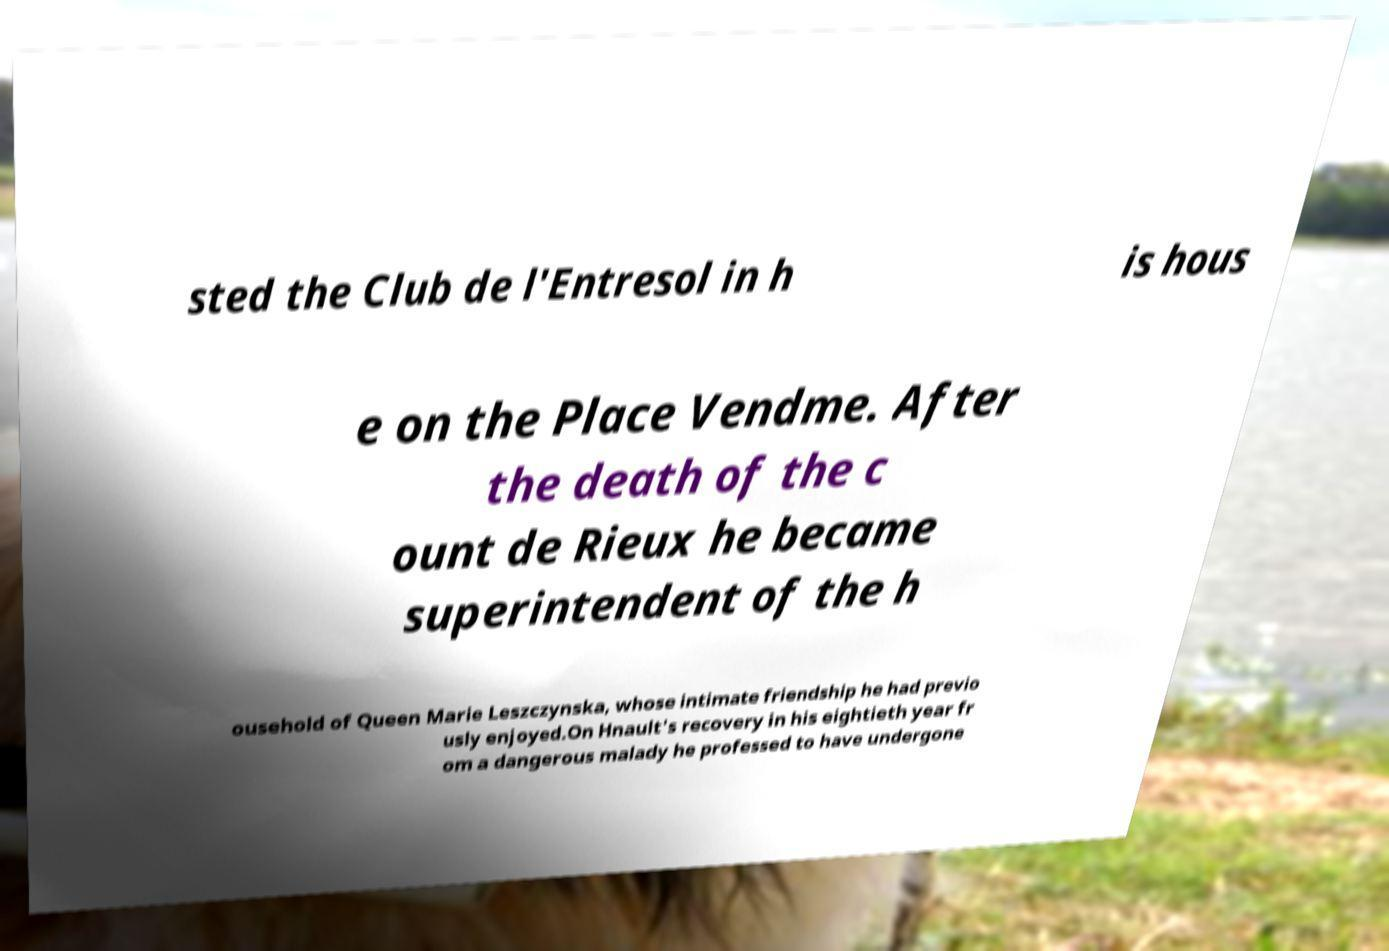Can you accurately transcribe the text from the provided image for me? sted the Club de l'Entresol in h is hous e on the Place Vendme. After the death of the c ount de Rieux he became superintendent of the h ousehold of Queen Marie Leszczynska, whose intimate friendship he had previo usly enjoyed.On Hnault's recovery in his eightieth year fr om a dangerous malady he professed to have undergone 